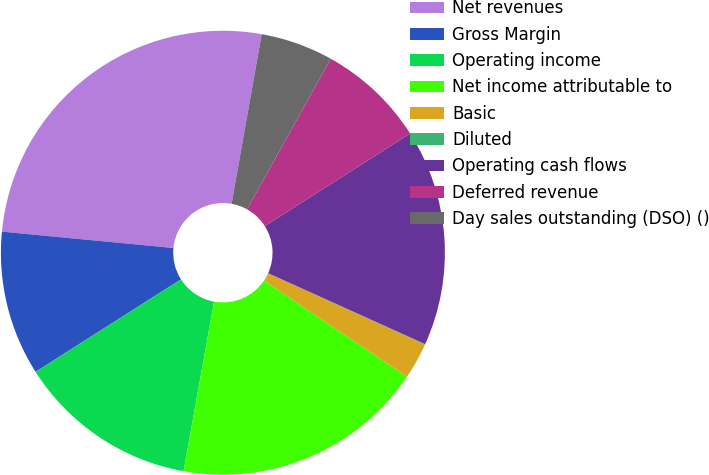<chart> <loc_0><loc_0><loc_500><loc_500><pie_chart><fcel>Net revenues<fcel>Gross Margin<fcel>Operating income<fcel>Net income attributable to<fcel>Basic<fcel>Diluted<fcel>Operating cash flows<fcel>Deferred revenue<fcel>Day sales outstanding (DSO) ()<nl><fcel>26.28%<fcel>10.53%<fcel>13.15%<fcel>18.4%<fcel>2.65%<fcel>0.03%<fcel>15.78%<fcel>7.9%<fcel>5.28%<nl></chart> 